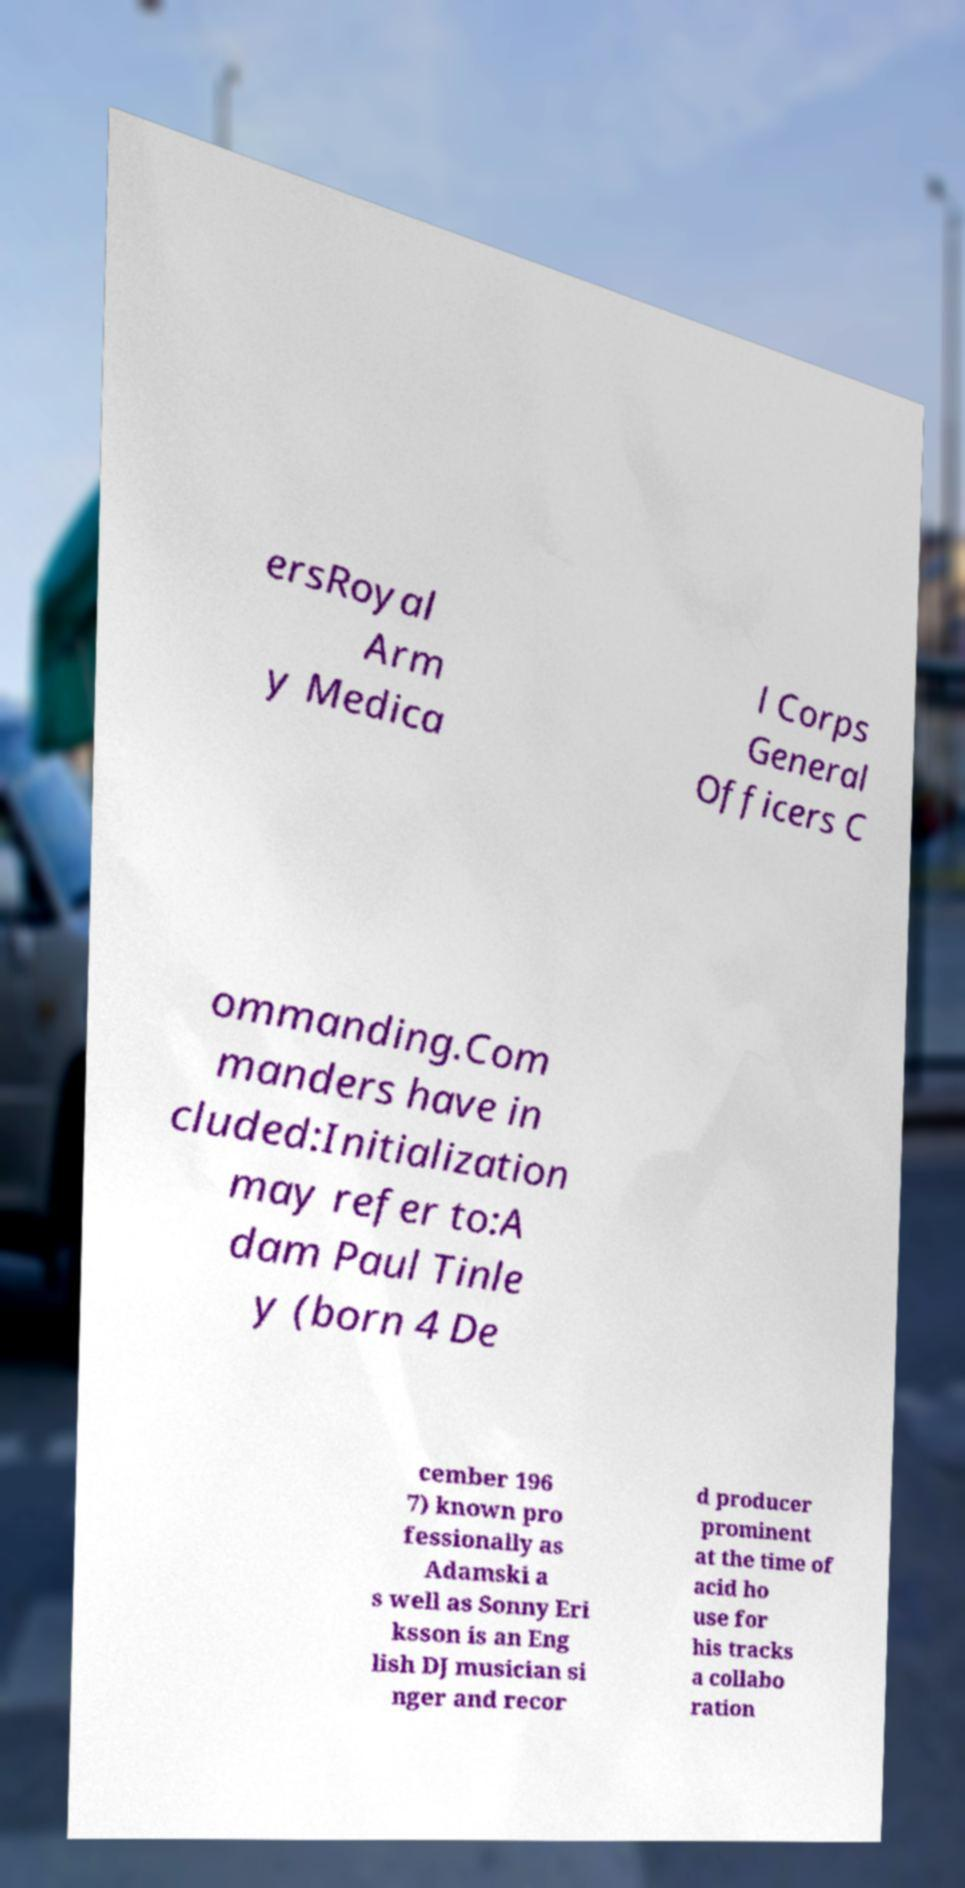Could you extract and type out the text from this image? ersRoyal Arm y Medica l Corps General Officers C ommanding.Com manders have in cluded:Initialization may refer to:A dam Paul Tinle y (born 4 De cember 196 7) known pro fessionally as Adamski a s well as Sonny Eri ksson is an Eng lish DJ musician si nger and recor d producer prominent at the time of acid ho use for his tracks a collabo ration 